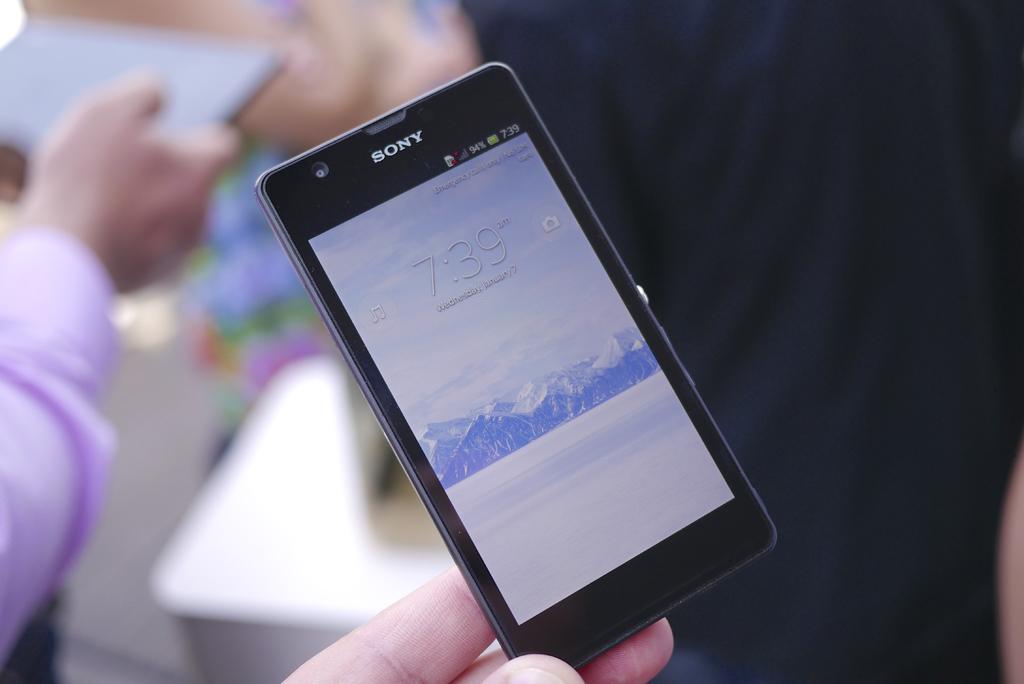What brand is this phone?
Make the answer very short. Sony. 